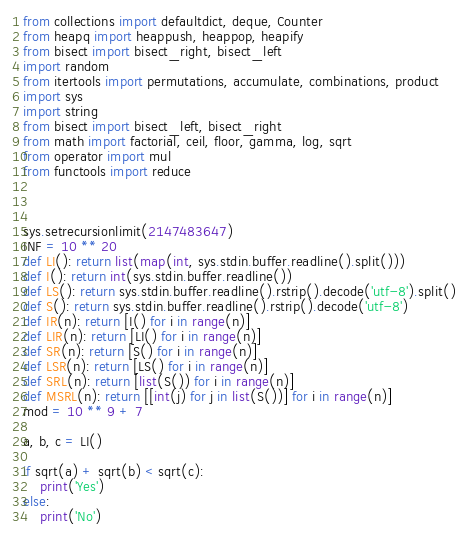<code> <loc_0><loc_0><loc_500><loc_500><_Python_>from collections import defaultdict, deque, Counter
from heapq import heappush, heappop, heapify
from bisect import bisect_right, bisect_left
import random
from itertools import permutations, accumulate, combinations, product
import sys
import string
from bisect import bisect_left, bisect_right
from math import factorial, ceil, floor, gamma, log, sqrt
from operator import mul
from functools import reduce



sys.setrecursionlimit(2147483647)
INF = 10 ** 20
def LI(): return list(map(int, sys.stdin.buffer.readline().split()))
def I(): return int(sys.stdin.buffer.readline())
def LS(): return sys.stdin.buffer.readline().rstrip().decode('utf-8').split()
def S(): return sys.stdin.buffer.readline().rstrip().decode('utf-8')
def IR(n): return [I() for i in range(n)]
def LIR(n): return [LI() for i in range(n)]
def SR(n): return [S() for i in range(n)]
def LSR(n): return [LS() for i in range(n)]
def SRL(n): return [list(S()) for i in range(n)]
def MSRL(n): return [[int(j) for j in list(S())] for i in range(n)]
mod = 10 ** 9 + 7

a, b, c = LI()

if sqrt(a) + sqrt(b) < sqrt(c):
    print('Yes')
else:
    print('No')</code> 